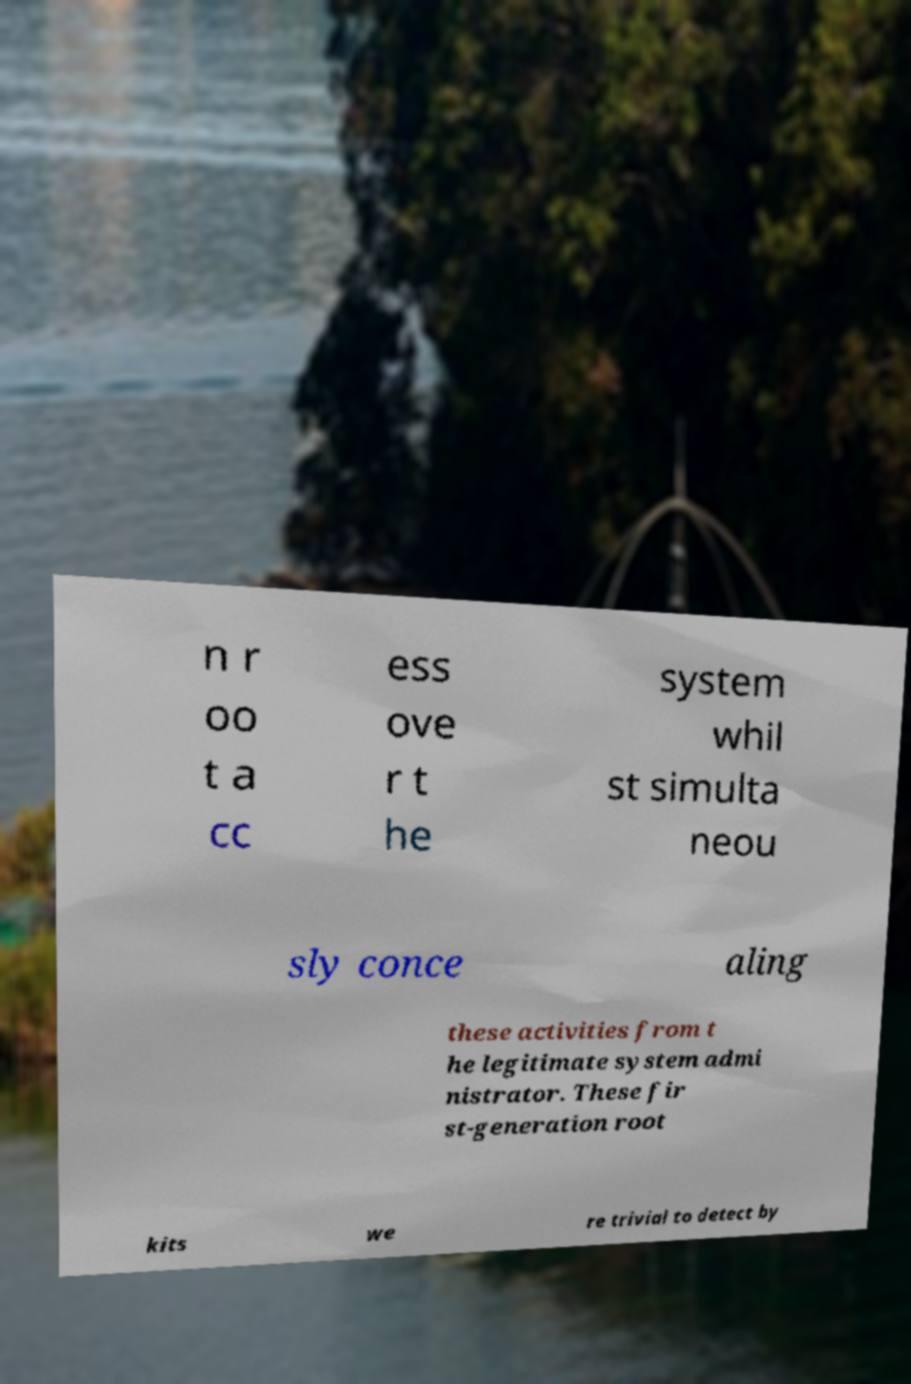What messages or text are displayed in this image? I need them in a readable, typed format. n r oo t a cc ess ove r t he system whil st simulta neou sly conce aling these activities from t he legitimate system admi nistrator. These fir st-generation root kits we re trivial to detect by 